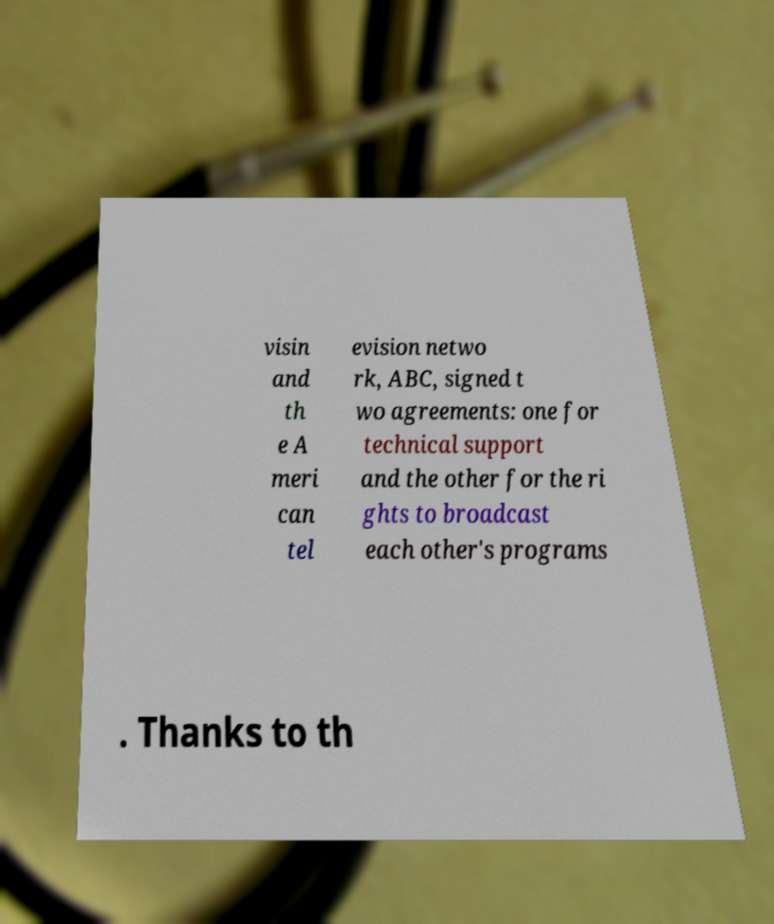Can you accurately transcribe the text from the provided image for me? visin and th e A meri can tel evision netwo rk, ABC, signed t wo agreements: one for technical support and the other for the ri ghts to broadcast each other's programs . Thanks to th 